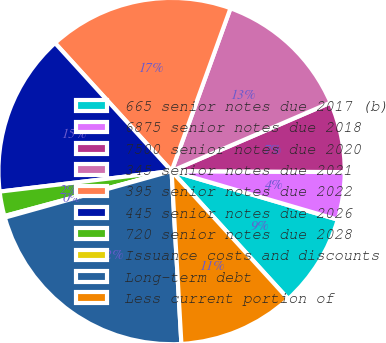Convert chart. <chart><loc_0><loc_0><loc_500><loc_500><pie_chart><fcel>665 senior notes due 2017 (b)<fcel>6875 senior notes due 2018<fcel>7500 senior notes due 2020<fcel>345 senior notes due 2021<fcel>395 senior notes due 2022<fcel>445 senior notes due 2026<fcel>720 senior notes due 2028<fcel>Issuance costs and discounts<fcel>Long-term debt<fcel>Less current portion of<nl><fcel>8.71%<fcel>4.43%<fcel>6.57%<fcel>13.0%<fcel>17.28%<fcel>15.14%<fcel>2.29%<fcel>0.15%<fcel>21.57%<fcel>10.86%<nl></chart> 